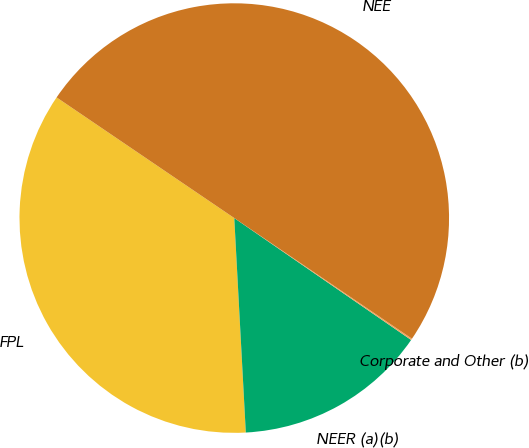Convert chart. <chart><loc_0><loc_0><loc_500><loc_500><pie_chart><fcel>FPL<fcel>NEER (a)(b)<fcel>Corporate and Other (b)<fcel>NEE<nl><fcel>35.35%<fcel>14.54%<fcel>0.11%<fcel>50.0%<nl></chart> 